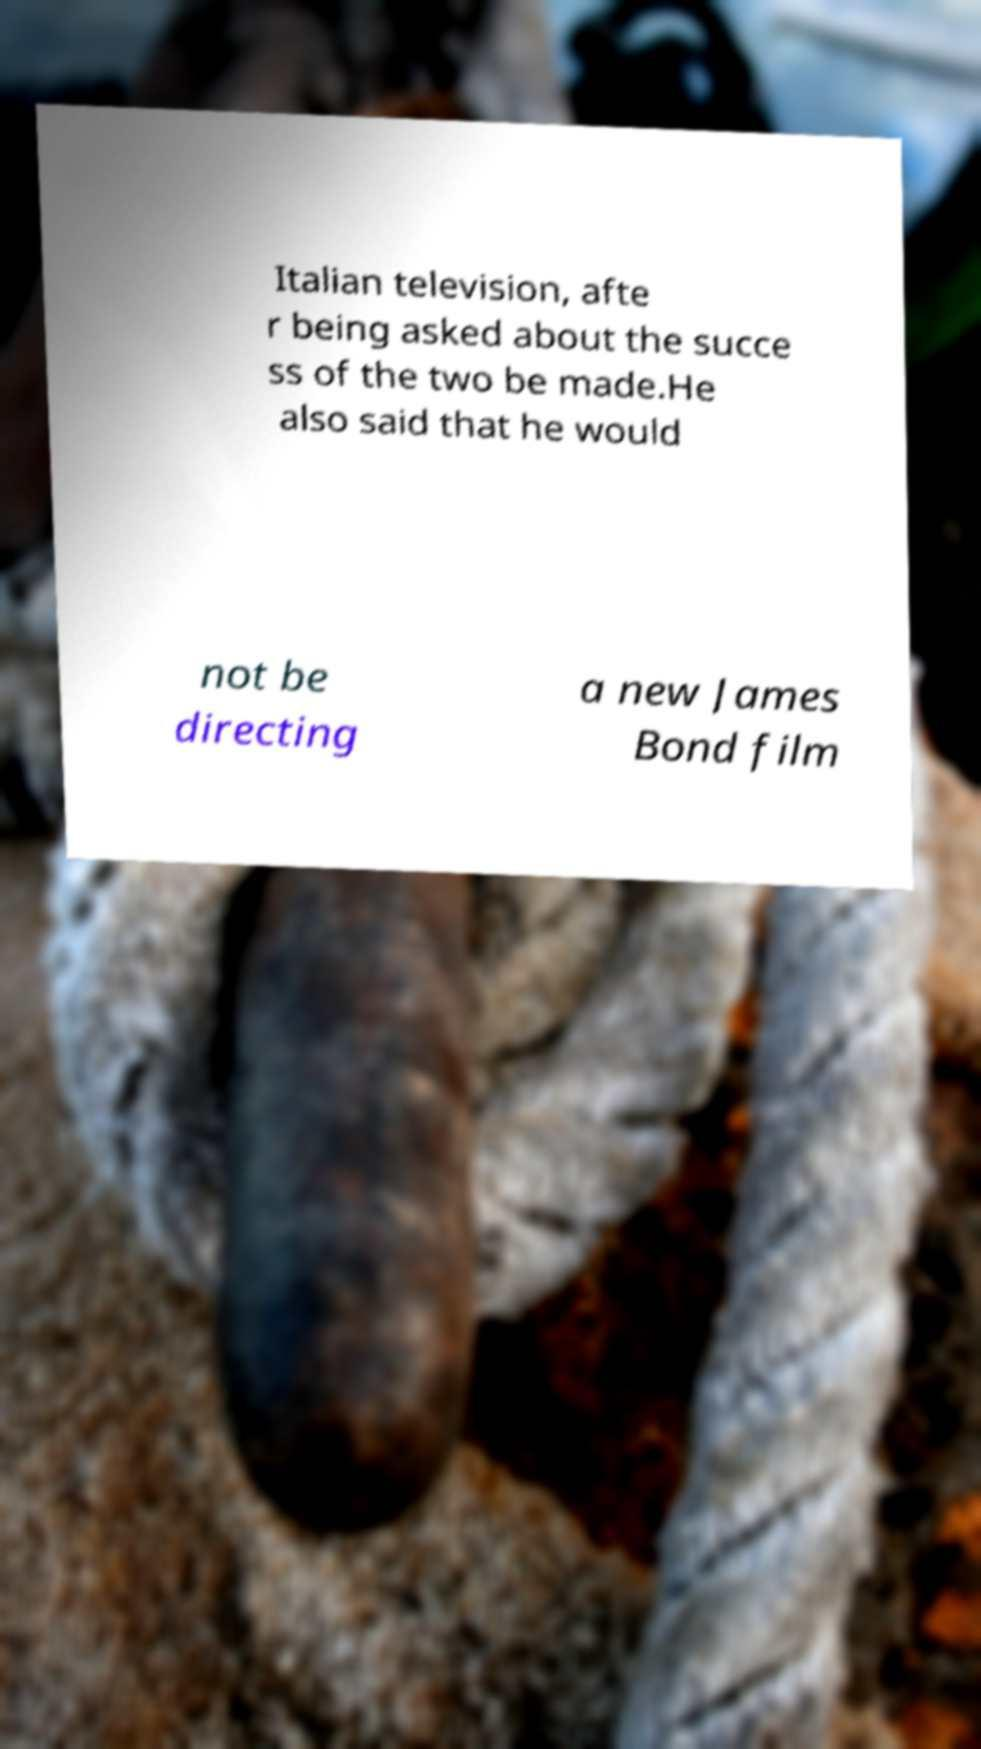Please identify and transcribe the text found in this image. Italian television, afte r being asked about the succe ss of the two be made.He also said that he would not be directing a new James Bond film 